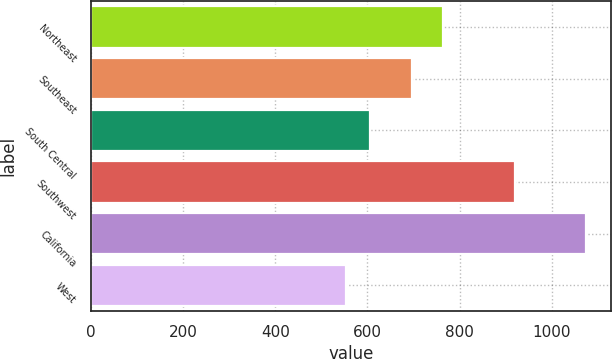Convert chart. <chart><loc_0><loc_0><loc_500><loc_500><bar_chart><fcel>Northeast<fcel>Southeast<fcel>South Central<fcel>Southwest<fcel>California<fcel>West<nl><fcel>763.4<fcel>697<fcel>606.22<fcel>919.6<fcel>1074.4<fcel>554.2<nl></chart> 